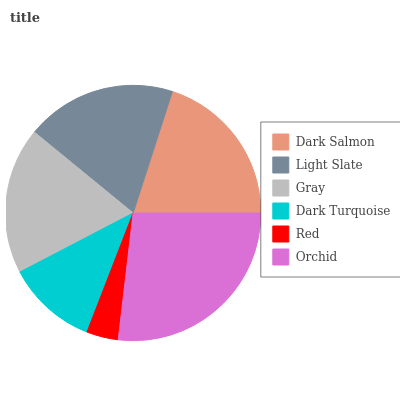Is Red the minimum?
Answer yes or no. Yes. Is Orchid the maximum?
Answer yes or no. Yes. Is Light Slate the minimum?
Answer yes or no. No. Is Light Slate the maximum?
Answer yes or no. No. Is Dark Salmon greater than Light Slate?
Answer yes or no. Yes. Is Light Slate less than Dark Salmon?
Answer yes or no. Yes. Is Light Slate greater than Dark Salmon?
Answer yes or no. No. Is Dark Salmon less than Light Slate?
Answer yes or no. No. Is Light Slate the high median?
Answer yes or no. Yes. Is Gray the low median?
Answer yes or no. Yes. Is Gray the high median?
Answer yes or no. No. Is Dark Salmon the low median?
Answer yes or no. No. 